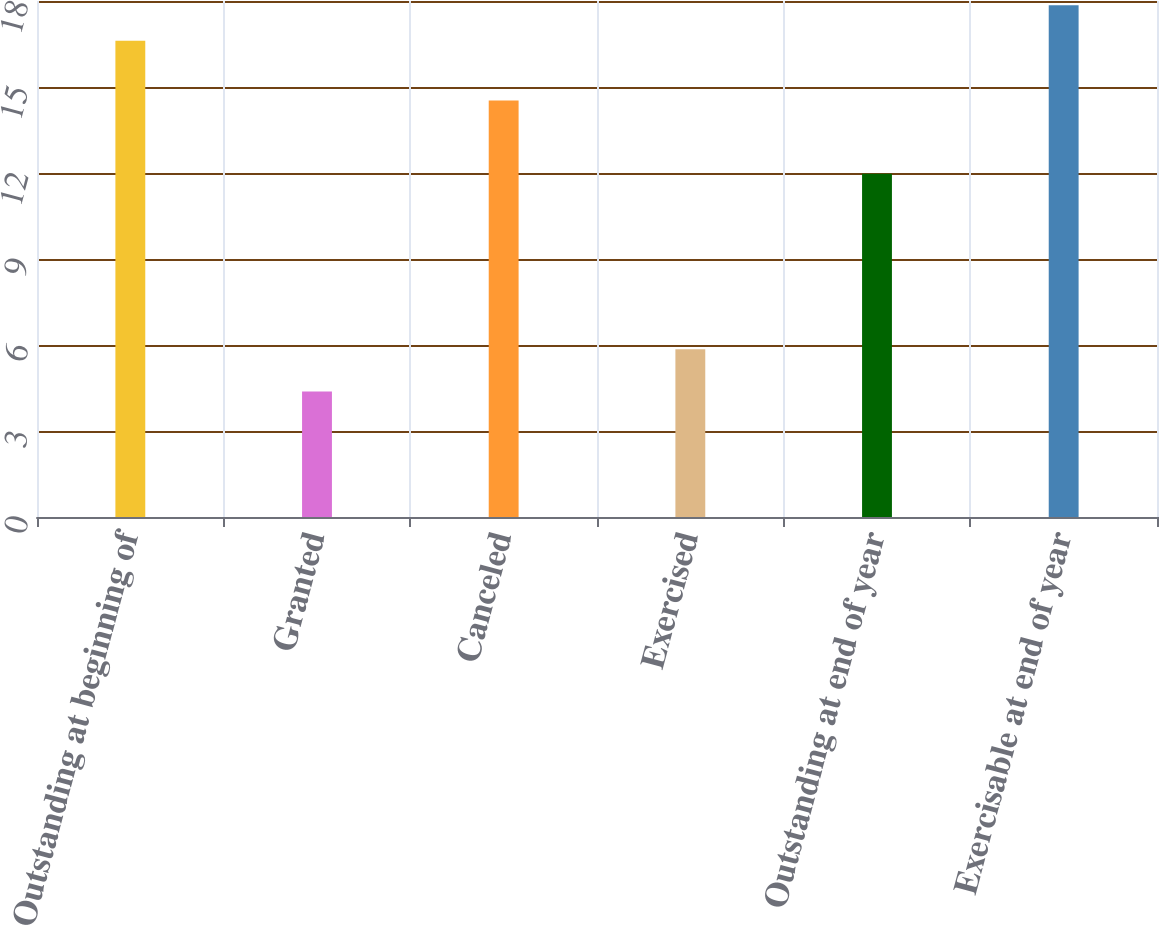<chart> <loc_0><loc_0><loc_500><loc_500><bar_chart><fcel>Outstanding at beginning of<fcel>Granted<fcel>Canceled<fcel>Exercised<fcel>Outstanding at end of year<fcel>Exercisable at end of year<nl><fcel>16.61<fcel>4.38<fcel>14.53<fcel>5.85<fcel>11.97<fcel>17.85<nl></chart> 